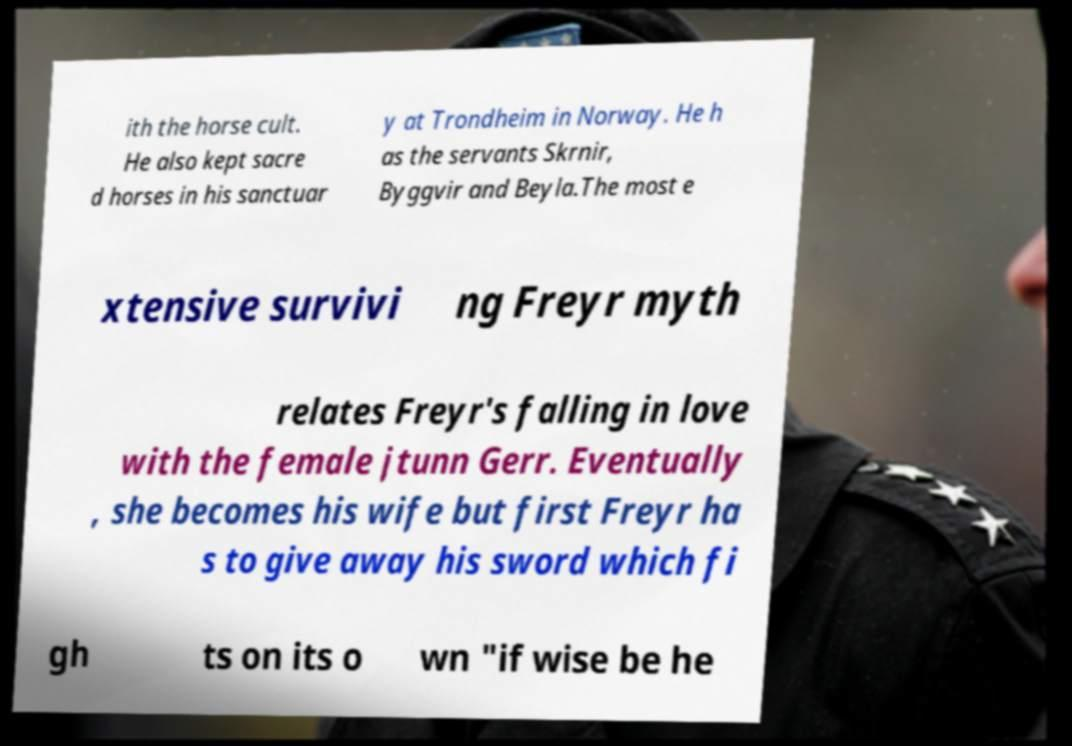Could you extract and type out the text from this image? ith the horse cult. He also kept sacre d horses in his sanctuar y at Trondheim in Norway. He h as the servants Skrnir, Byggvir and Beyla.The most e xtensive survivi ng Freyr myth relates Freyr's falling in love with the female jtunn Gerr. Eventually , she becomes his wife but first Freyr ha s to give away his sword which fi gh ts on its o wn "if wise be he 